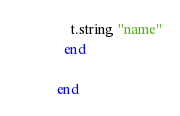<code> <loc_0><loc_0><loc_500><loc_500><_Ruby_>    t.string "name"
  end

end
</code> 